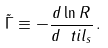<formula> <loc_0><loc_0><loc_500><loc_500>\tilde { \Gamma } \equiv - \frac { d \ln R } { d \ t i l _ { s } } \, .</formula> 